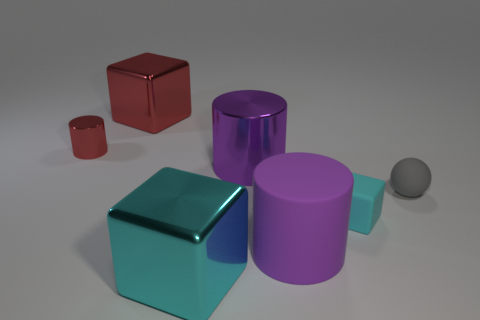Subtract all purple rubber cylinders. How many cylinders are left? 2 Add 3 tiny yellow blocks. How many objects exist? 10 Subtract all red cylinders. How many cylinders are left? 2 Subtract all yellow cylinders. How many cyan balls are left? 0 Subtract 0 green cylinders. How many objects are left? 7 Subtract all cylinders. How many objects are left? 4 Subtract 1 blocks. How many blocks are left? 2 Subtract all cyan cylinders. Subtract all gray spheres. How many cylinders are left? 3 Subtract all small gray balls. Subtract all big cylinders. How many objects are left? 4 Add 3 big purple rubber cylinders. How many big purple rubber cylinders are left? 4 